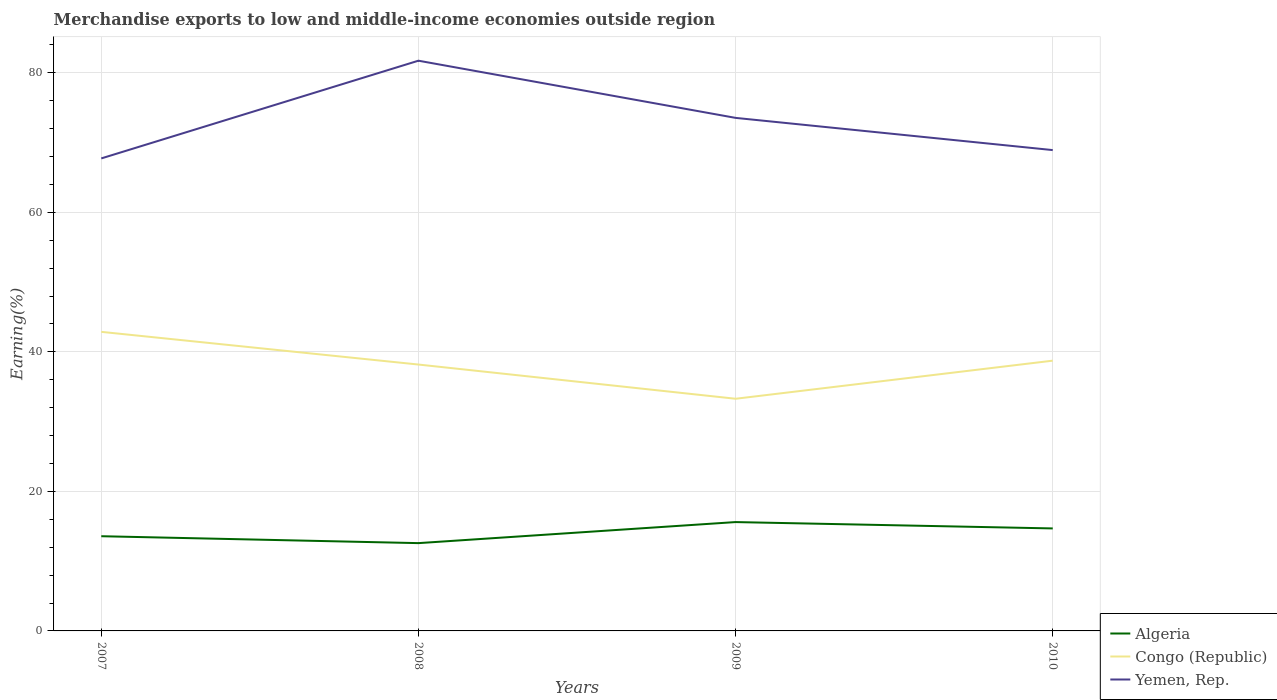Is the number of lines equal to the number of legend labels?
Provide a short and direct response. Yes. Across all years, what is the maximum percentage of amount earned from merchandise exports in Algeria?
Offer a very short reply. 12.59. In which year was the percentage of amount earned from merchandise exports in Congo (Republic) maximum?
Keep it short and to the point. 2009. What is the total percentage of amount earned from merchandise exports in Yemen, Rep. in the graph?
Your answer should be very brief. 4.62. What is the difference between the highest and the second highest percentage of amount earned from merchandise exports in Yemen, Rep.?
Keep it short and to the point. 14.01. Is the percentage of amount earned from merchandise exports in Yemen, Rep. strictly greater than the percentage of amount earned from merchandise exports in Congo (Republic) over the years?
Your answer should be compact. No. How many lines are there?
Offer a terse response. 3. How many years are there in the graph?
Make the answer very short. 4. Does the graph contain any zero values?
Ensure brevity in your answer.  No. Does the graph contain grids?
Provide a short and direct response. Yes. Where does the legend appear in the graph?
Make the answer very short. Bottom right. What is the title of the graph?
Provide a short and direct response. Merchandise exports to low and middle-income economies outside region. Does "Somalia" appear as one of the legend labels in the graph?
Provide a succinct answer. No. What is the label or title of the X-axis?
Your response must be concise. Years. What is the label or title of the Y-axis?
Ensure brevity in your answer.  Earning(%). What is the Earning(%) of Algeria in 2007?
Offer a terse response. 13.58. What is the Earning(%) in Congo (Republic) in 2007?
Provide a succinct answer. 42.87. What is the Earning(%) in Yemen, Rep. in 2007?
Your answer should be compact. 67.73. What is the Earning(%) in Algeria in 2008?
Your response must be concise. 12.59. What is the Earning(%) in Congo (Republic) in 2008?
Offer a terse response. 38.19. What is the Earning(%) in Yemen, Rep. in 2008?
Give a very brief answer. 81.74. What is the Earning(%) in Algeria in 2009?
Offer a terse response. 15.6. What is the Earning(%) of Congo (Republic) in 2009?
Keep it short and to the point. 33.28. What is the Earning(%) in Yemen, Rep. in 2009?
Give a very brief answer. 73.55. What is the Earning(%) of Algeria in 2010?
Make the answer very short. 14.69. What is the Earning(%) of Congo (Republic) in 2010?
Give a very brief answer. 38.74. What is the Earning(%) of Yemen, Rep. in 2010?
Provide a succinct answer. 68.93. Across all years, what is the maximum Earning(%) in Algeria?
Ensure brevity in your answer.  15.6. Across all years, what is the maximum Earning(%) in Congo (Republic)?
Your response must be concise. 42.87. Across all years, what is the maximum Earning(%) in Yemen, Rep.?
Your answer should be very brief. 81.74. Across all years, what is the minimum Earning(%) in Algeria?
Offer a terse response. 12.59. Across all years, what is the minimum Earning(%) in Congo (Republic)?
Your response must be concise. 33.28. Across all years, what is the minimum Earning(%) of Yemen, Rep.?
Provide a short and direct response. 67.73. What is the total Earning(%) of Algeria in the graph?
Provide a short and direct response. 56.46. What is the total Earning(%) in Congo (Republic) in the graph?
Provide a succinct answer. 153.08. What is the total Earning(%) in Yemen, Rep. in the graph?
Keep it short and to the point. 291.95. What is the difference between the Earning(%) in Algeria in 2007 and that in 2008?
Offer a very short reply. 0.99. What is the difference between the Earning(%) of Congo (Republic) in 2007 and that in 2008?
Give a very brief answer. 4.69. What is the difference between the Earning(%) of Yemen, Rep. in 2007 and that in 2008?
Provide a short and direct response. -14.01. What is the difference between the Earning(%) in Algeria in 2007 and that in 2009?
Give a very brief answer. -2.03. What is the difference between the Earning(%) in Congo (Republic) in 2007 and that in 2009?
Offer a very short reply. 9.59. What is the difference between the Earning(%) in Yemen, Rep. in 2007 and that in 2009?
Make the answer very short. -5.81. What is the difference between the Earning(%) in Algeria in 2007 and that in 2010?
Provide a succinct answer. -1.12. What is the difference between the Earning(%) of Congo (Republic) in 2007 and that in 2010?
Your answer should be compact. 4.13. What is the difference between the Earning(%) in Yemen, Rep. in 2007 and that in 2010?
Offer a very short reply. -1.19. What is the difference between the Earning(%) of Algeria in 2008 and that in 2009?
Your answer should be compact. -3.02. What is the difference between the Earning(%) of Congo (Republic) in 2008 and that in 2009?
Make the answer very short. 4.9. What is the difference between the Earning(%) of Yemen, Rep. in 2008 and that in 2009?
Your response must be concise. 8.2. What is the difference between the Earning(%) of Algeria in 2008 and that in 2010?
Your answer should be very brief. -2.11. What is the difference between the Earning(%) of Congo (Republic) in 2008 and that in 2010?
Your answer should be very brief. -0.55. What is the difference between the Earning(%) in Yemen, Rep. in 2008 and that in 2010?
Make the answer very short. 12.81. What is the difference between the Earning(%) in Algeria in 2009 and that in 2010?
Offer a very short reply. 0.91. What is the difference between the Earning(%) of Congo (Republic) in 2009 and that in 2010?
Ensure brevity in your answer.  -5.46. What is the difference between the Earning(%) of Yemen, Rep. in 2009 and that in 2010?
Your response must be concise. 4.62. What is the difference between the Earning(%) in Algeria in 2007 and the Earning(%) in Congo (Republic) in 2008?
Keep it short and to the point. -24.61. What is the difference between the Earning(%) in Algeria in 2007 and the Earning(%) in Yemen, Rep. in 2008?
Give a very brief answer. -68.17. What is the difference between the Earning(%) of Congo (Republic) in 2007 and the Earning(%) of Yemen, Rep. in 2008?
Provide a short and direct response. -38.87. What is the difference between the Earning(%) in Algeria in 2007 and the Earning(%) in Congo (Republic) in 2009?
Your answer should be compact. -19.71. What is the difference between the Earning(%) of Algeria in 2007 and the Earning(%) of Yemen, Rep. in 2009?
Your answer should be compact. -59.97. What is the difference between the Earning(%) of Congo (Republic) in 2007 and the Earning(%) of Yemen, Rep. in 2009?
Your answer should be very brief. -30.67. What is the difference between the Earning(%) in Algeria in 2007 and the Earning(%) in Congo (Republic) in 2010?
Offer a very short reply. -25.17. What is the difference between the Earning(%) of Algeria in 2007 and the Earning(%) of Yemen, Rep. in 2010?
Your response must be concise. -55.35. What is the difference between the Earning(%) in Congo (Republic) in 2007 and the Earning(%) in Yemen, Rep. in 2010?
Your answer should be very brief. -26.06. What is the difference between the Earning(%) in Algeria in 2008 and the Earning(%) in Congo (Republic) in 2009?
Your response must be concise. -20.7. What is the difference between the Earning(%) in Algeria in 2008 and the Earning(%) in Yemen, Rep. in 2009?
Offer a very short reply. -60.96. What is the difference between the Earning(%) in Congo (Republic) in 2008 and the Earning(%) in Yemen, Rep. in 2009?
Ensure brevity in your answer.  -35.36. What is the difference between the Earning(%) of Algeria in 2008 and the Earning(%) of Congo (Republic) in 2010?
Your answer should be compact. -26.16. What is the difference between the Earning(%) in Algeria in 2008 and the Earning(%) in Yemen, Rep. in 2010?
Offer a very short reply. -56.34. What is the difference between the Earning(%) in Congo (Republic) in 2008 and the Earning(%) in Yemen, Rep. in 2010?
Make the answer very short. -30.74. What is the difference between the Earning(%) in Algeria in 2009 and the Earning(%) in Congo (Republic) in 2010?
Offer a terse response. -23.14. What is the difference between the Earning(%) of Algeria in 2009 and the Earning(%) of Yemen, Rep. in 2010?
Keep it short and to the point. -53.32. What is the difference between the Earning(%) in Congo (Republic) in 2009 and the Earning(%) in Yemen, Rep. in 2010?
Your answer should be compact. -35.65. What is the average Earning(%) of Algeria per year?
Your response must be concise. 14.11. What is the average Earning(%) of Congo (Republic) per year?
Your answer should be very brief. 38.27. What is the average Earning(%) in Yemen, Rep. per year?
Offer a very short reply. 72.99. In the year 2007, what is the difference between the Earning(%) in Algeria and Earning(%) in Congo (Republic)?
Your answer should be very brief. -29.3. In the year 2007, what is the difference between the Earning(%) of Algeria and Earning(%) of Yemen, Rep.?
Offer a very short reply. -54.16. In the year 2007, what is the difference between the Earning(%) in Congo (Republic) and Earning(%) in Yemen, Rep.?
Your response must be concise. -24.86. In the year 2008, what is the difference between the Earning(%) in Algeria and Earning(%) in Congo (Republic)?
Your response must be concise. -25.6. In the year 2008, what is the difference between the Earning(%) in Algeria and Earning(%) in Yemen, Rep.?
Keep it short and to the point. -69.16. In the year 2008, what is the difference between the Earning(%) of Congo (Republic) and Earning(%) of Yemen, Rep.?
Offer a terse response. -43.56. In the year 2009, what is the difference between the Earning(%) in Algeria and Earning(%) in Congo (Republic)?
Offer a very short reply. -17.68. In the year 2009, what is the difference between the Earning(%) of Algeria and Earning(%) of Yemen, Rep.?
Ensure brevity in your answer.  -57.94. In the year 2009, what is the difference between the Earning(%) in Congo (Republic) and Earning(%) in Yemen, Rep.?
Offer a very short reply. -40.26. In the year 2010, what is the difference between the Earning(%) in Algeria and Earning(%) in Congo (Republic)?
Offer a very short reply. -24.05. In the year 2010, what is the difference between the Earning(%) in Algeria and Earning(%) in Yemen, Rep.?
Your response must be concise. -54.24. In the year 2010, what is the difference between the Earning(%) in Congo (Republic) and Earning(%) in Yemen, Rep.?
Keep it short and to the point. -30.19. What is the ratio of the Earning(%) of Algeria in 2007 to that in 2008?
Ensure brevity in your answer.  1.08. What is the ratio of the Earning(%) of Congo (Republic) in 2007 to that in 2008?
Keep it short and to the point. 1.12. What is the ratio of the Earning(%) in Yemen, Rep. in 2007 to that in 2008?
Your answer should be very brief. 0.83. What is the ratio of the Earning(%) in Algeria in 2007 to that in 2009?
Make the answer very short. 0.87. What is the ratio of the Earning(%) of Congo (Republic) in 2007 to that in 2009?
Provide a short and direct response. 1.29. What is the ratio of the Earning(%) in Yemen, Rep. in 2007 to that in 2009?
Give a very brief answer. 0.92. What is the ratio of the Earning(%) in Algeria in 2007 to that in 2010?
Your answer should be compact. 0.92. What is the ratio of the Earning(%) of Congo (Republic) in 2007 to that in 2010?
Provide a short and direct response. 1.11. What is the ratio of the Earning(%) of Yemen, Rep. in 2007 to that in 2010?
Make the answer very short. 0.98. What is the ratio of the Earning(%) in Algeria in 2008 to that in 2009?
Your answer should be compact. 0.81. What is the ratio of the Earning(%) of Congo (Republic) in 2008 to that in 2009?
Your response must be concise. 1.15. What is the ratio of the Earning(%) of Yemen, Rep. in 2008 to that in 2009?
Offer a very short reply. 1.11. What is the ratio of the Earning(%) of Algeria in 2008 to that in 2010?
Give a very brief answer. 0.86. What is the ratio of the Earning(%) in Congo (Republic) in 2008 to that in 2010?
Ensure brevity in your answer.  0.99. What is the ratio of the Earning(%) in Yemen, Rep. in 2008 to that in 2010?
Offer a very short reply. 1.19. What is the ratio of the Earning(%) of Algeria in 2009 to that in 2010?
Provide a short and direct response. 1.06. What is the ratio of the Earning(%) in Congo (Republic) in 2009 to that in 2010?
Make the answer very short. 0.86. What is the ratio of the Earning(%) in Yemen, Rep. in 2009 to that in 2010?
Your answer should be compact. 1.07. What is the difference between the highest and the second highest Earning(%) in Algeria?
Make the answer very short. 0.91. What is the difference between the highest and the second highest Earning(%) of Congo (Republic)?
Offer a terse response. 4.13. What is the difference between the highest and the second highest Earning(%) of Yemen, Rep.?
Your response must be concise. 8.2. What is the difference between the highest and the lowest Earning(%) of Algeria?
Keep it short and to the point. 3.02. What is the difference between the highest and the lowest Earning(%) in Congo (Republic)?
Ensure brevity in your answer.  9.59. What is the difference between the highest and the lowest Earning(%) in Yemen, Rep.?
Provide a succinct answer. 14.01. 